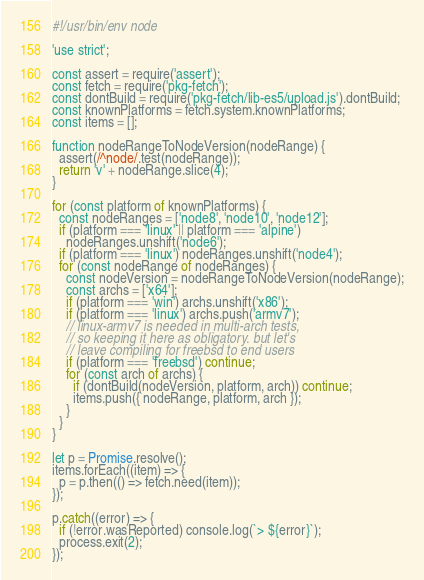Convert code to text. <code><loc_0><loc_0><loc_500><loc_500><_JavaScript_>#!/usr/bin/env node

'use strict';

const assert = require('assert');
const fetch = require('pkg-fetch');
const dontBuild = require('pkg-fetch/lib-es5/upload.js').dontBuild;
const knownPlatforms = fetch.system.knownPlatforms;
const items = [];

function nodeRangeToNodeVersion(nodeRange) {
  assert(/^node/.test(nodeRange));
  return 'v' + nodeRange.slice(4);
}

for (const platform of knownPlatforms) {
  const nodeRanges = ['node8', 'node10', 'node12'];
  if (platform === 'linux' || platform === 'alpine')
    nodeRanges.unshift('node6');
  if (platform === 'linux') nodeRanges.unshift('node4');
  for (const nodeRange of nodeRanges) {
    const nodeVersion = nodeRangeToNodeVersion(nodeRange);
    const archs = ['x64'];
    if (platform === 'win') archs.unshift('x86');
    if (platform === 'linux') archs.push('armv7');
    // linux-armv7 is needed in multi-arch tests,
    // so keeping it here as obligatory. but let's
    // leave compiling for freebsd to end users
    if (platform === 'freebsd') continue;
    for (const arch of archs) {
      if (dontBuild(nodeVersion, platform, arch)) continue;
      items.push({ nodeRange, platform, arch });
    }
  }
}

let p = Promise.resolve();
items.forEach((item) => {
  p = p.then(() => fetch.need(item));
});

p.catch((error) => {
  if (!error.wasReported) console.log(`> ${error}`);
  process.exit(2);
});
</code> 